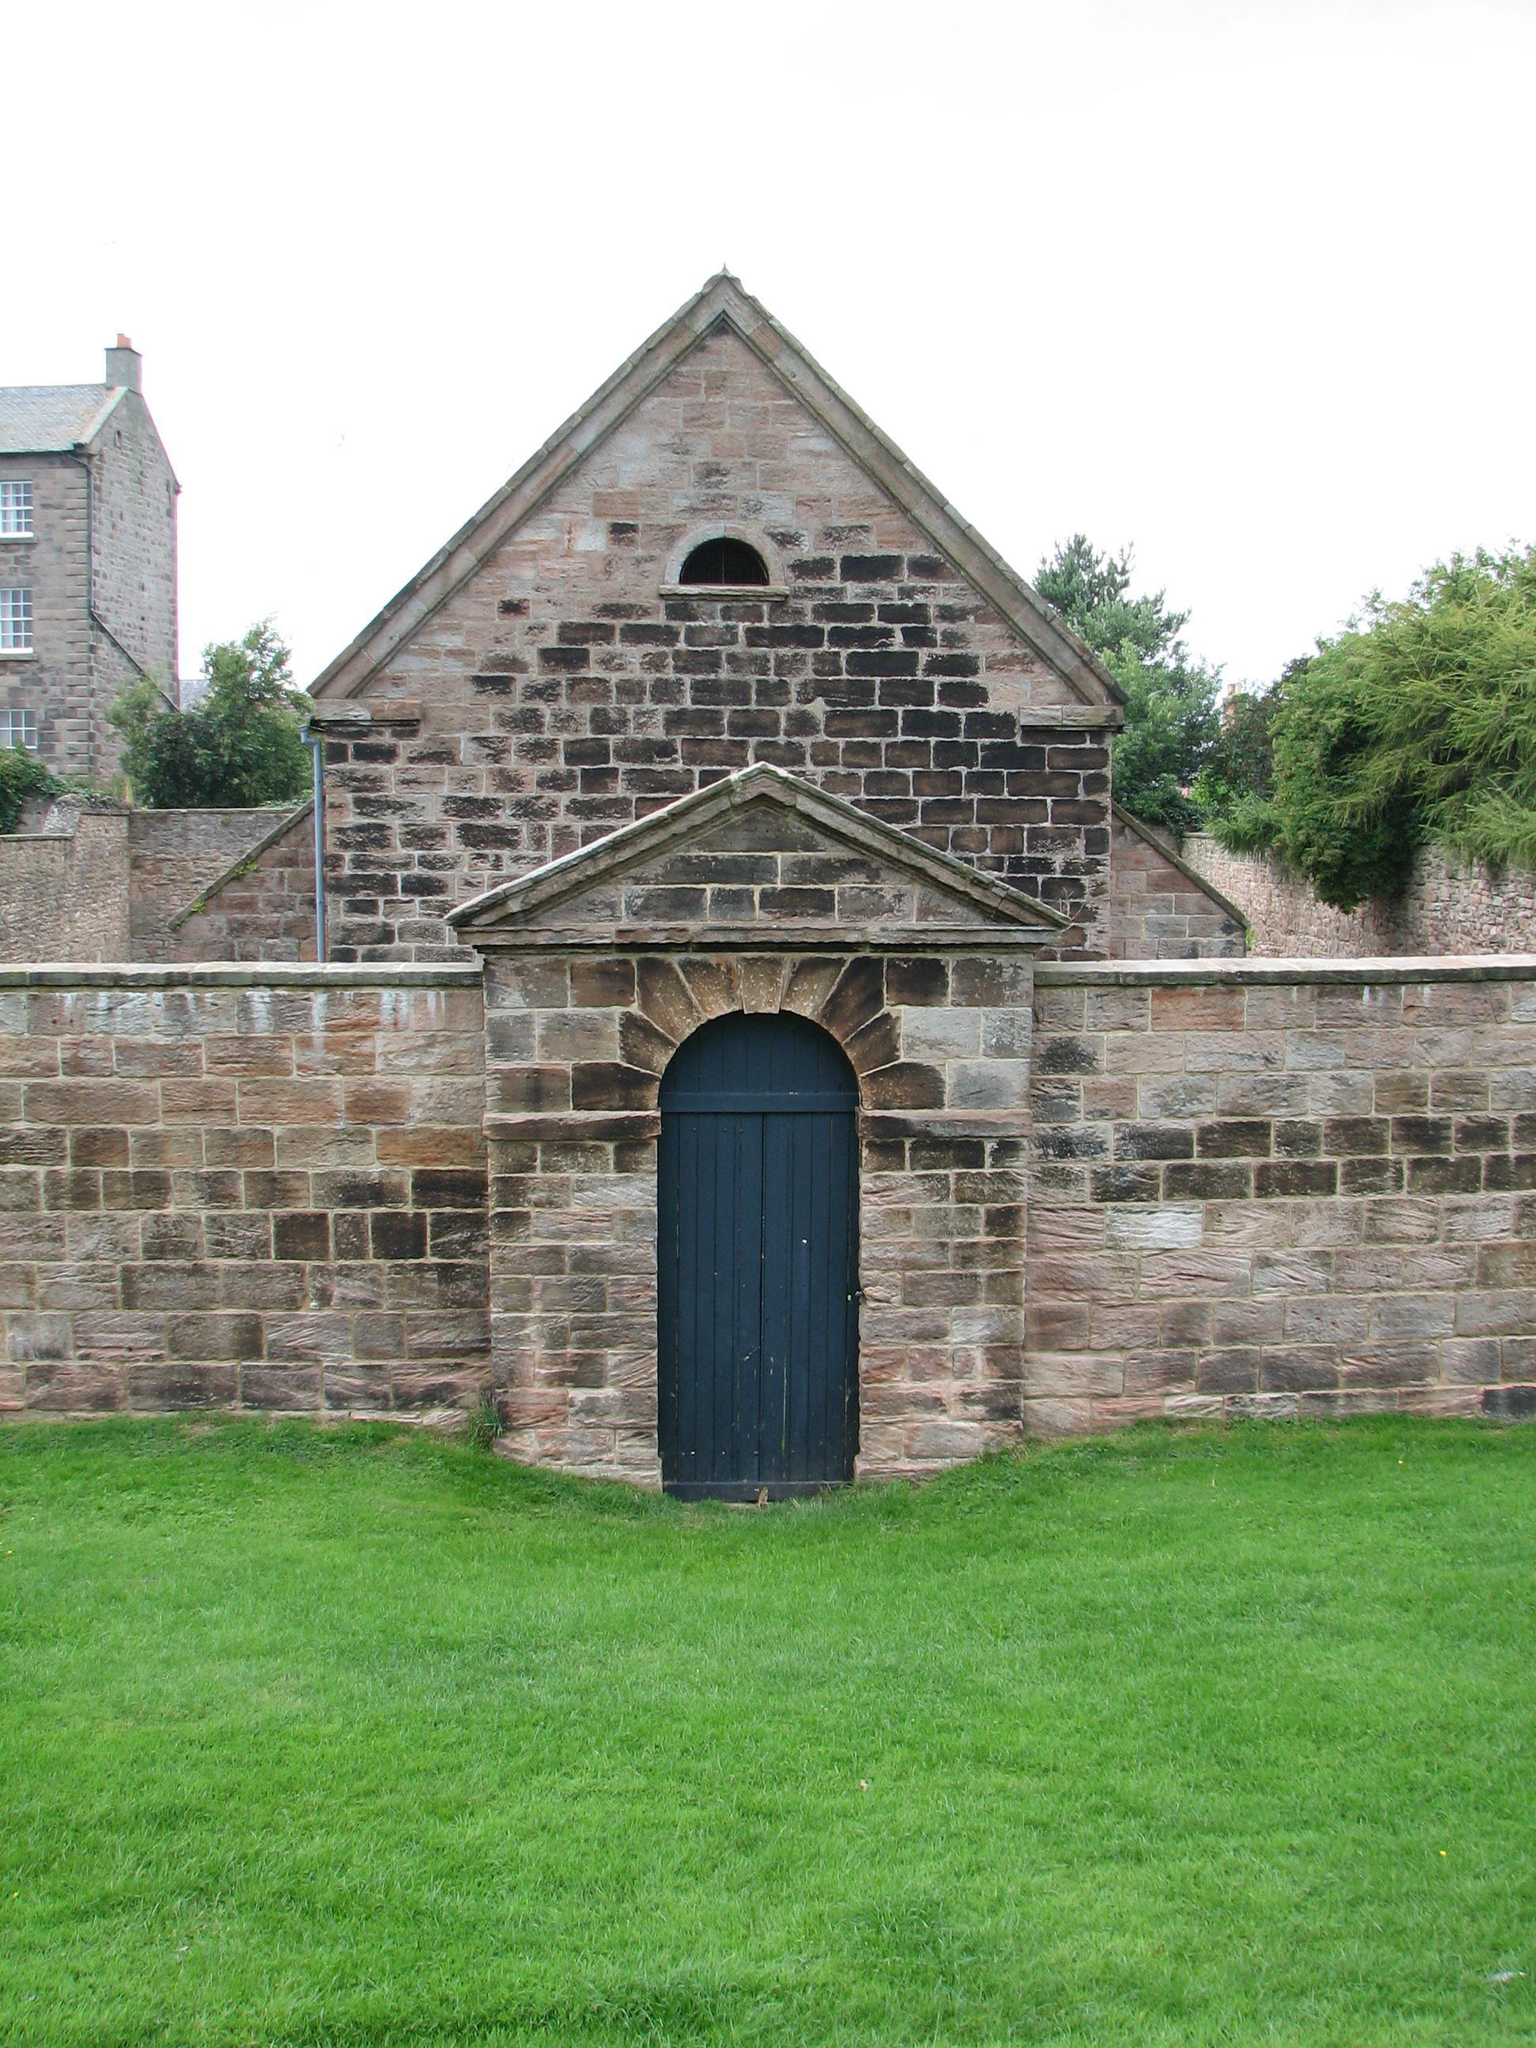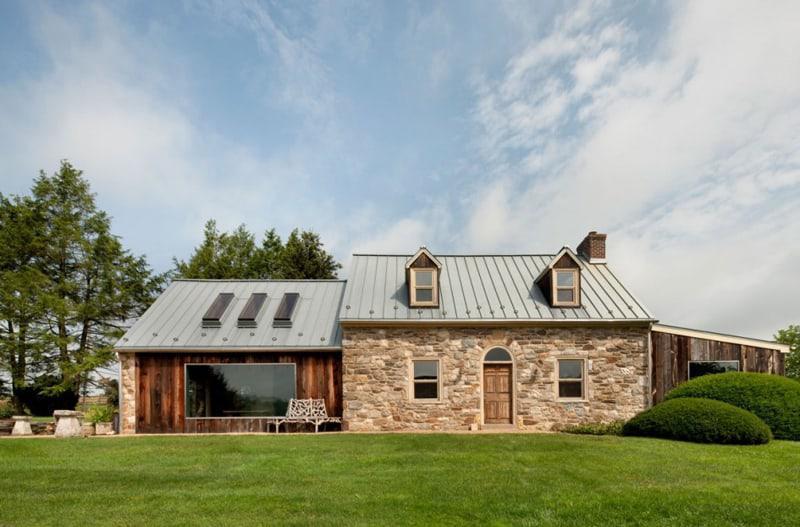The first image is the image on the left, the second image is the image on the right. Evaluate the accuracy of this statement regarding the images: "There is a cozy white house on a level ground with trees behind it.". Is it true? Answer yes or no. No. 